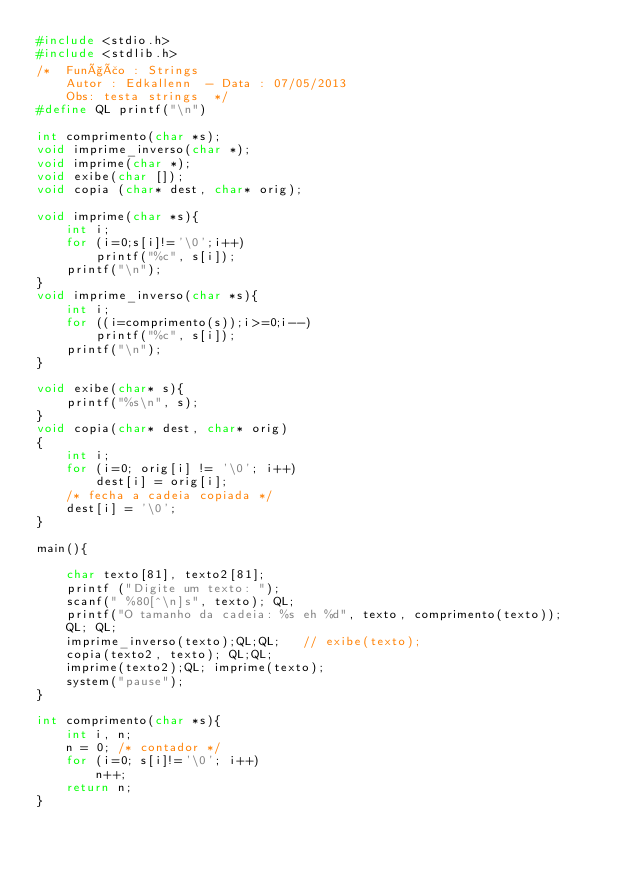Convert code to text. <code><loc_0><loc_0><loc_500><loc_500><_C++_>#include <stdio.h>
#include <stdlib.h>
/*  Função : Strings
    Autor : Edkallenn  - Data : 07/05/2013
    Obs: testa strings  */
#define QL printf("\n")

int comprimento(char *s);
void imprime_inverso(char *);
void imprime(char *);
void exibe(char []);
void copia (char* dest, char* orig);

void imprime(char *s){
    int i;
    for (i=0;s[i]!='\0';i++)
        printf("%c", s[i]);
    printf("\n");
}
void imprime_inverso(char *s){
    int i;
    for ((i=comprimento(s));i>=0;i--)
        printf("%c", s[i]);
    printf("\n");
}

void exibe(char* s){
    printf("%s\n", s);
}
void copia(char* dest, char* orig)
{
    int i;
    for (i=0; orig[i] != '\0'; i++)
        dest[i] = orig[i];
    /* fecha a cadeia copiada */
    dest[i] = '\0';
}

main(){

    char texto[81], texto2[81];
    printf ("Digite um texto: ");
    scanf(" %80[^\n]s", texto); QL;
    printf("O tamanho da cadeia: %s eh %d", texto, comprimento(texto));
    QL; QL;
    imprime_inverso(texto);QL;QL;   // exibe(texto);
    copia(texto2, texto); QL;QL;
    imprime(texto2);QL; imprime(texto);
    system("pause");
}

int comprimento(char *s){
    int i, n;
    n = 0; /* contador */
    for (i=0; s[i]!='\0'; i++)
        n++;
    return n;
}


</code> 